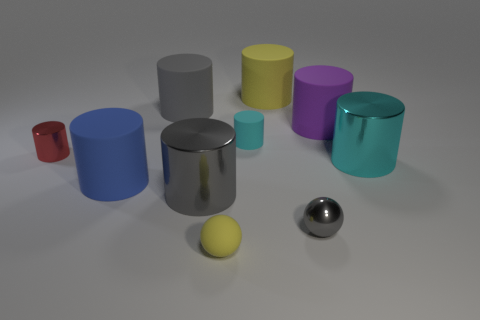Subtract all purple cylinders. How many cylinders are left? 7 Subtract all green spheres. How many cyan cylinders are left? 2 Subtract 6 cylinders. How many cylinders are left? 2 Subtract all red cylinders. How many cylinders are left? 7 Subtract all cylinders. How many objects are left? 2 Add 8 blue things. How many blue things exist? 9 Subtract 1 red cylinders. How many objects are left? 9 Subtract all cyan cylinders. Subtract all yellow blocks. How many cylinders are left? 6 Subtract all purple cylinders. Subtract all large cyan cylinders. How many objects are left? 8 Add 7 purple rubber objects. How many purple rubber objects are left? 8 